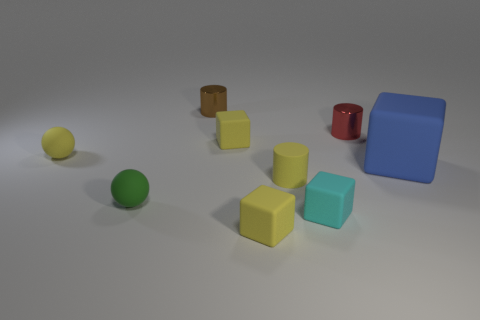Add 1 small brown matte cylinders. How many objects exist? 10 Subtract all spheres. How many objects are left? 7 Add 6 tiny rubber cubes. How many tiny rubber cubes are left? 9 Add 7 tiny red metal things. How many tiny red metal things exist? 8 Subtract 0 cyan spheres. How many objects are left? 9 Subtract all purple rubber cylinders. Subtract all brown cylinders. How many objects are left? 8 